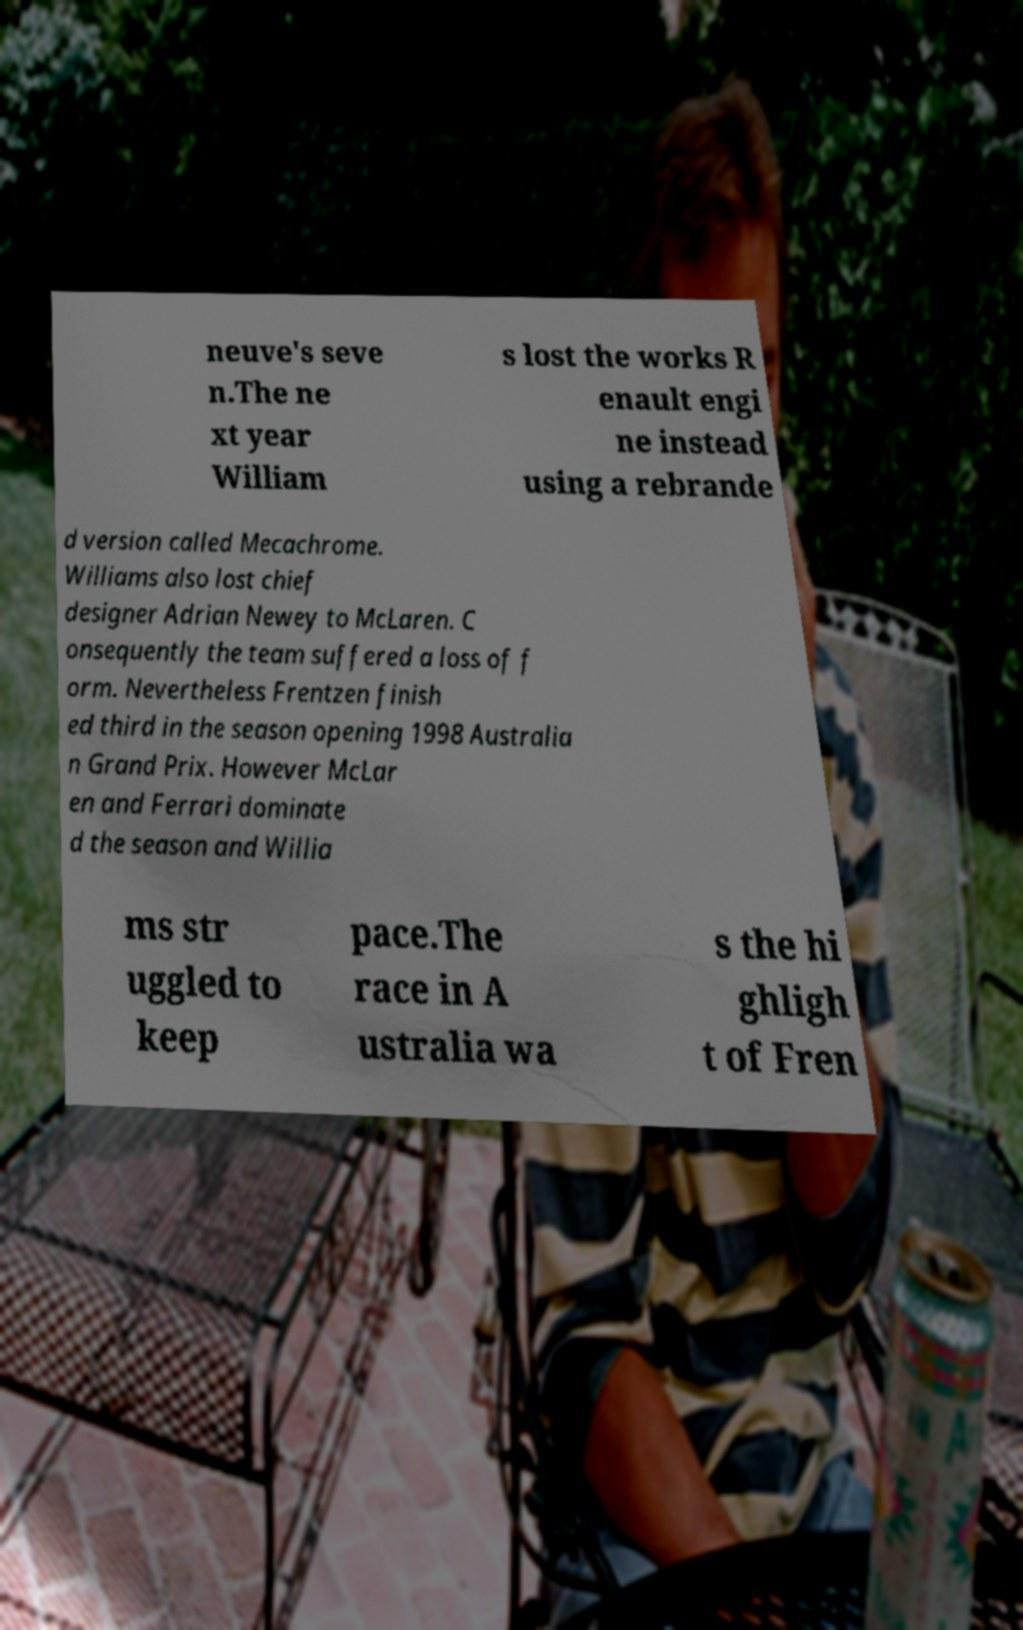Please read and relay the text visible in this image. What does it say? neuve's seve n.The ne xt year William s lost the works R enault engi ne instead using a rebrande d version called Mecachrome. Williams also lost chief designer Adrian Newey to McLaren. C onsequently the team suffered a loss of f orm. Nevertheless Frentzen finish ed third in the season opening 1998 Australia n Grand Prix. However McLar en and Ferrari dominate d the season and Willia ms str uggled to keep pace.The race in A ustralia wa s the hi ghligh t of Fren 